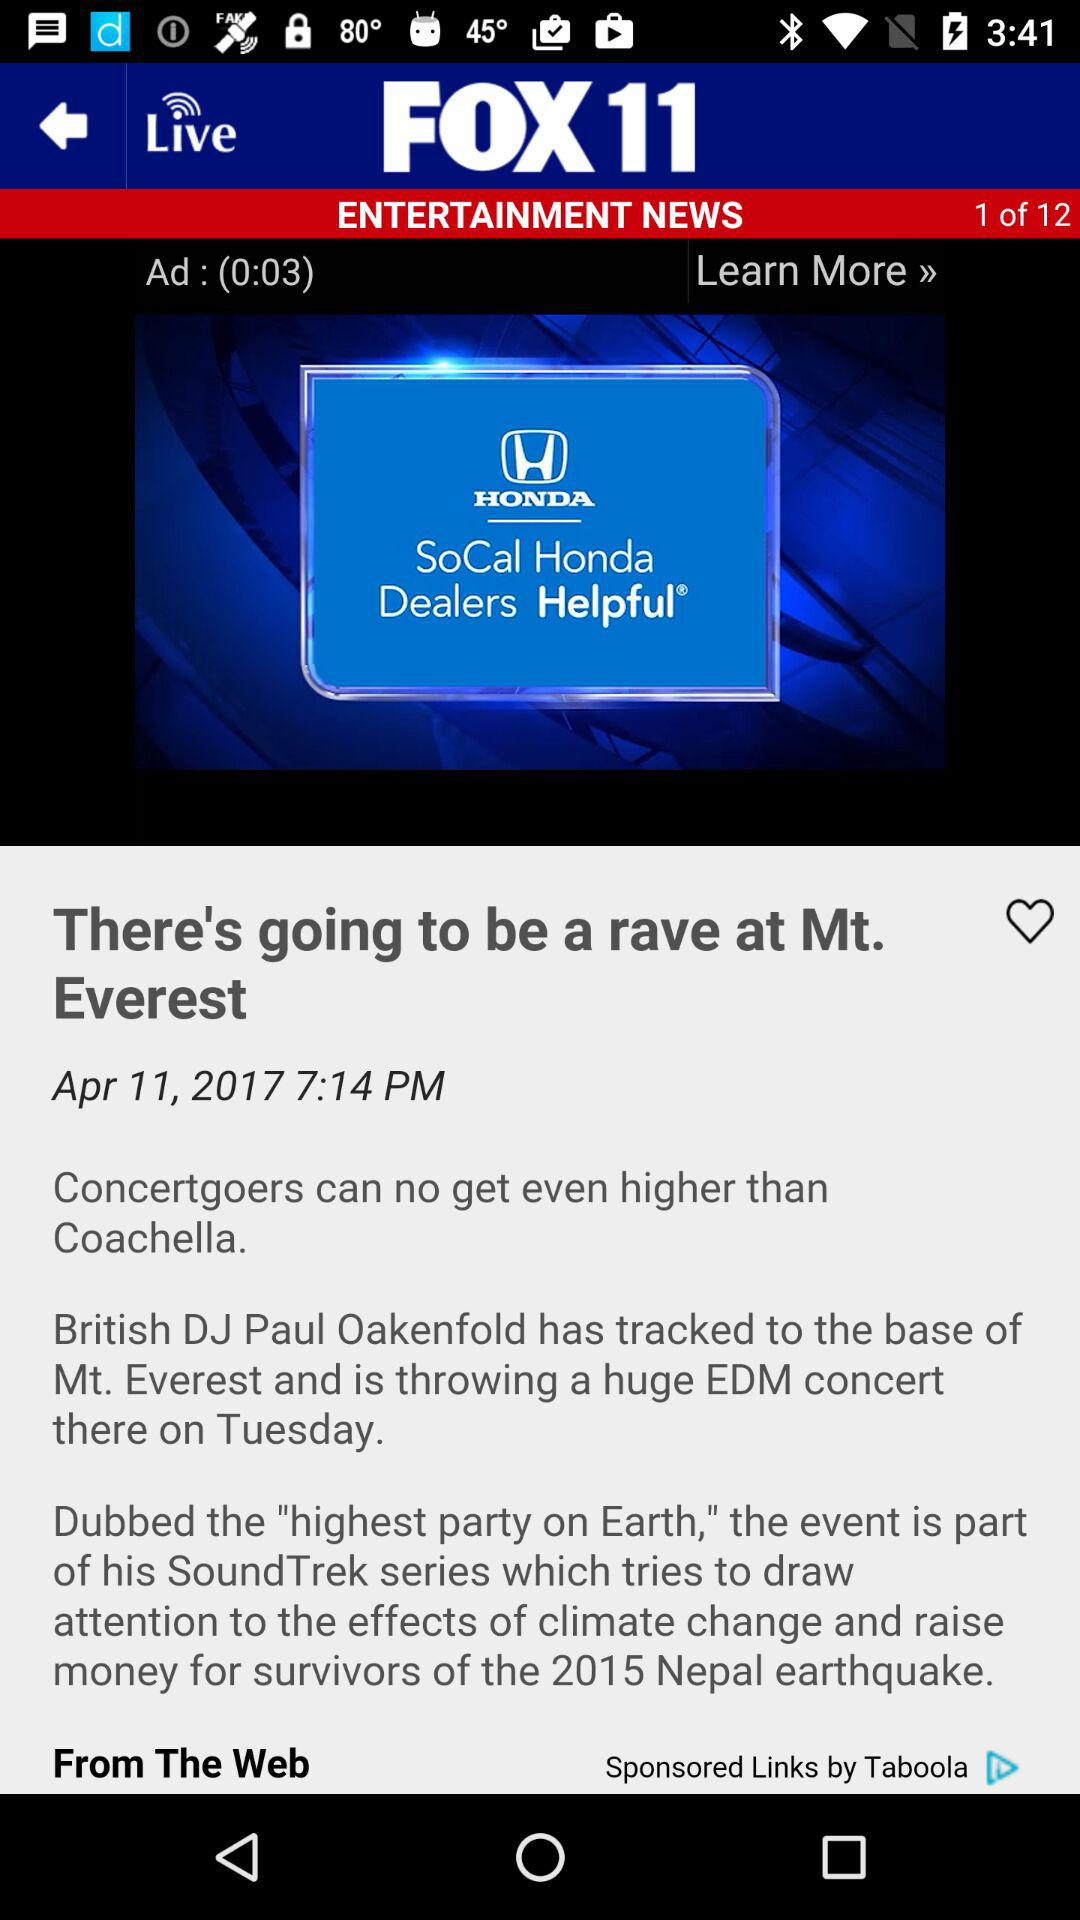What is the time duration for an advertisement video? The duration of an advertisement video is 0:03. 